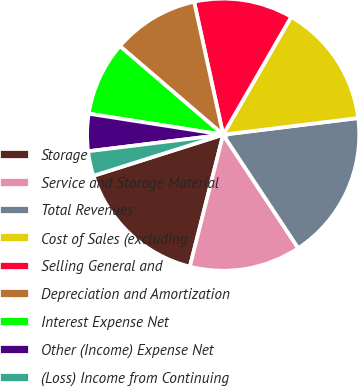Convert chart to OTSL. <chart><loc_0><loc_0><loc_500><loc_500><pie_chart><fcel>Storage<fcel>Service and Storage Material<fcel>Total Revenues<fcel>Cost of Sales (excluding<fcel>Selling General and<fcel>Depreciation and Amortization<fcel>Interest Expense Net<fcel>Other (Income) Expense Net<fcel>(Loss) Income from Continuing<nl><fcel>16.18%<fcel>13.24%<fcel>17.65%<fcel>14.71%<fcel>11.76%<fcel>10.29%<fcel>8.82%<fcel>4.41%<fcel>2.94%<nl></chart> 